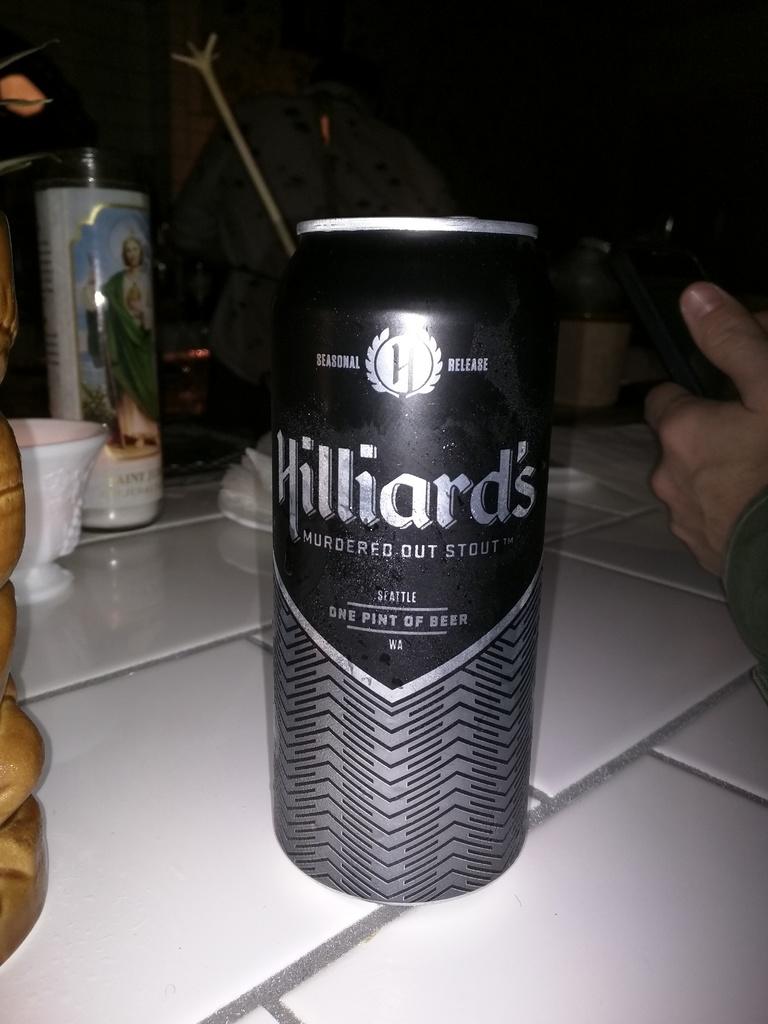What is the name of this drink?
Give a very brief answer. Hilliard's. 